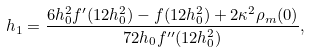Convert formula to latex. <formula><loc_0><loc_0><loc_500><loc_500>h _ { 1 } = \frac { 6 h _ { 0 } ^ { 2 } f ^ { \prime } ( 1 2 h _ { 0 } ^ { 2 } ) - f ( 1 2 h _ { 0 } ^ { 2 } ) + 2 \kappa ^ { 2 } \rho _ { m } ( 0 ) } { 7 2 h _ { 0 } f ^ { \prime \prime } ( 1 2 h _ { 0 } ^ { 2 } ) } ,</formula> 